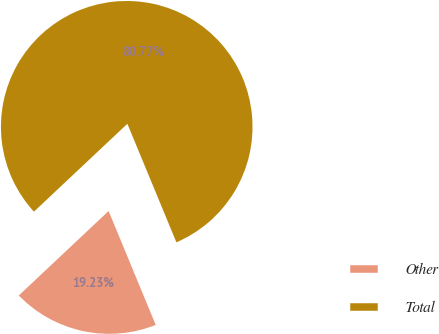Convert chart to OTSL. <chart><loc_0><loc_0><loc_500><loc_500><pie_chart><fcel>Other<fcel>Total<nl><fcel>19.23%<fcel>80.77%<nl></chart> 